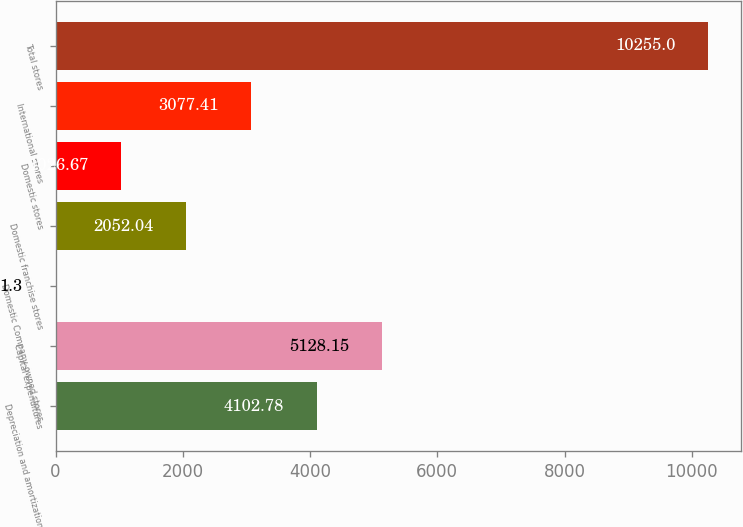Convert chart to OTSL. <chart><loc_0><loc_0><loc_500><loc_500><bar_chart><fcel>Depreciation and amortization<fcel>Capital expenditures<fcel>Domestic Company-owned stores<fcel>Domestic franchise stores<fcel>Domestic stores<fcel>International stores<fcel>Total stores<nl><fcel>4102.78<fcel>5128.15<fcel>1.3<fcel>2052.04<fcel>1026.67<fcel>3077.41<fcel>10255<nl></chart> 